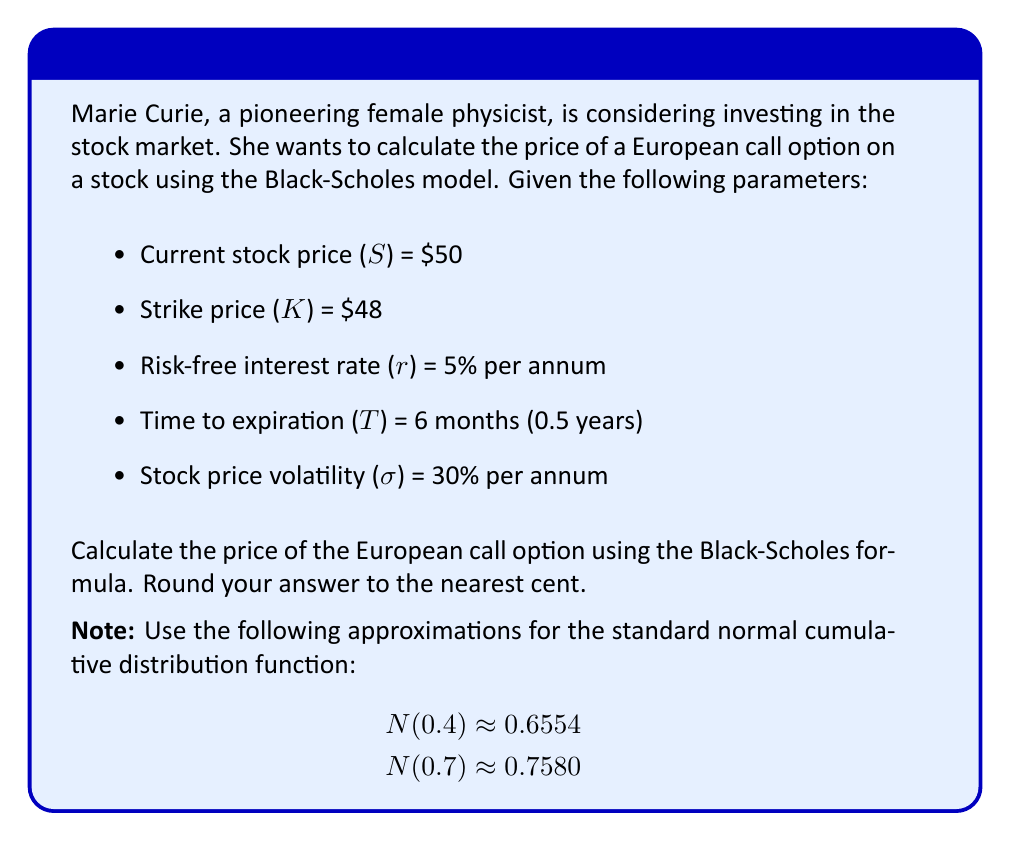Help me with this question. To calculate the price of a European call option using the Black-Scholes model, we'll follow these steps:

1. Calculate d₁ and d₂:
   $$d_1 = \frac{\ln(S/K) + (r + \sigma^2/2)T}{\sigma\sqrt{T}}$$
   $$d_2 = d_1 - \sigma\sqrt{T}$$

2. Find N(d₁) and N(d₂) using the given approximations.

3. Apply the Black-Scholes formula:
   $$C = SN(d_1) - Ke^{-rT}N(d_2)$$

Step 1: Calculate d₁ and d₂

$$d_1 = \frac{\ln(50/48) + (0.05 + 0.3^2/2)0.5}{0.3\sqrt{0.5}}$$
$$d_1 = \frac{0.0408 + (0.05 + 0.045)0.5}{0.3\sqrt{0.5}} = \frac{0.0408 + 0.0475}{0.2121} = 0.4162$$

$$d_2 = 0.4162 - 0.3\sqrt{0.5} = 0.4162 - 0.2121 = 0.2041$$

Step 2: Find N(d₁) and N(d₂)
N(d₁) ≈ N(0.4) ≈ 0.6554
N(d₂) ≈ N(0.2) ≈ 0.5793 (using linear interpolation between N(0) = 0.5 and N(0.4) = 0.6554)

Step 3: Apply the Black-Scholes formula

$$C = 50 \times 0.6554 - 48e^{-0.05 \times 0.5} \times 0.5793$$
$$C = 32.77 - 48 \times 0.9753 \times 0.5793$$
$$C = 32.77 - 27.09 = 5.68$$

Therefore, the price of the European call option is $5.68.
Answer: $5.68 